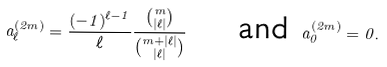<formula> <loc_0><loc_0><loc_500><loc_500>a _ { \ell } ^ { ( 2 m ) } = \frac { ( - 1 ) ^ { \ell - 1 } } { \ell } \frac { \binom { m } { | \ell | } } { \binom { m + | \ell | } { | \ell | } } \quad \text { and } a _ { 0 } ^ { ( 2 m ) } = 0 .</formula> 